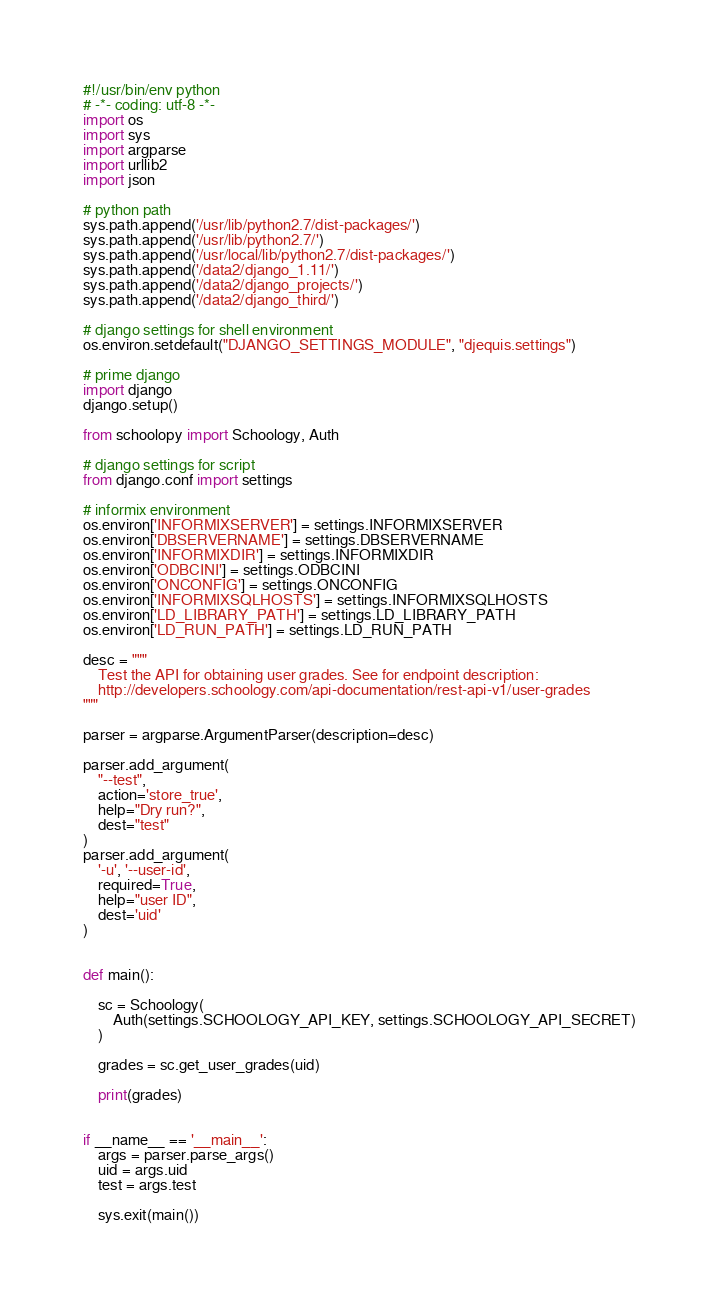Convert code to text. <code><loc_0><loc_0><loc_500><loc_500><_Python_>#!/usr/bin/env python
# -*- coding: utf-8 -*-
import os
import sys
import argparse
import urllib2
import json

# python path
sys.path.append('/usr/lib/python2.7/dist-packages/')
sys.path.append('/usr/lib/python2.7/')
sys.path.append('/usr/local/lib/python2.7/dist-packages/')
sys.path.append('/data2/django_1.11/')
sys.path.append('/data2/django_projects/')
sys.path.append('/data2/django_third/')

# django settings for shell environment
os.environ.setdefault("DJANGO_SETTINGS_MODULE", "djequis.settings")

# prime django
import django
django.setup()

from schoolopy import Schoology, Auth

# django settings for script
from django.conf import settings

# informix environment
os.environ['INFORMIXSERVER'] = settings.INFORMIXSERVER
os.environ['DBSERVERNAME'] = settings.DBSERVERNAME
os.environ['INFORMIXDIR'] = settings.INFORMIXDIR
os.environ['ODBCINI'] = settings.ODBCINI
os.environ['ONCONFIG'] = settings.ONCONFIG
os.environ['INFORMIXSQLHOSTS'] = settings.INFORMIXSQLHOSTS
os.environ['LD_LIBRARY_PATH'] = settings.LD_LIBRARY_PATH
os.environ['LD_RUN_PATH'] = settings.LD_RUN_PATH

desc = """
    Test the API for obtaining user grades. See for endpoint description:
    http://developers.schoology.com/api-documentation/rest-api-v1/user-grades
"""

parser = argparse.ArgumentParser(description=desc)

parser.add_argument(
    "--test",
    action='store_true',
    help="Dry run?",
    dest="test"
)
parser.add_argument(
    '-u', '--user-id',
    required=True,
    help="user ID",
    dest='uid'
)


def main():

    sc = Schoology(
        Auth(settings.SCHOOLOGY_API_KEY, settings.SCHOOLOGY_API_SECRET)
    )

    grades = sc.get_user_grades(uid)

    print(grades)


if __name__ == '__main__':
    args = parser.parse_args()
    uid = args.uid
    test = args.test

    sys.exit(main())
</code> 